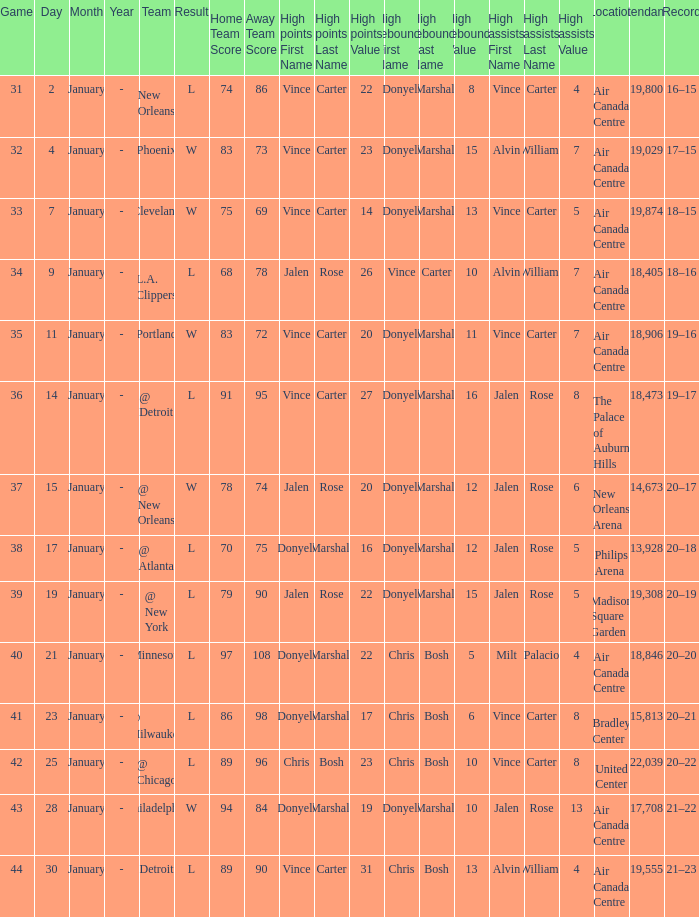What is the Location and Attendance with a Record of 21–22? Air Canada Centre 17,708. 